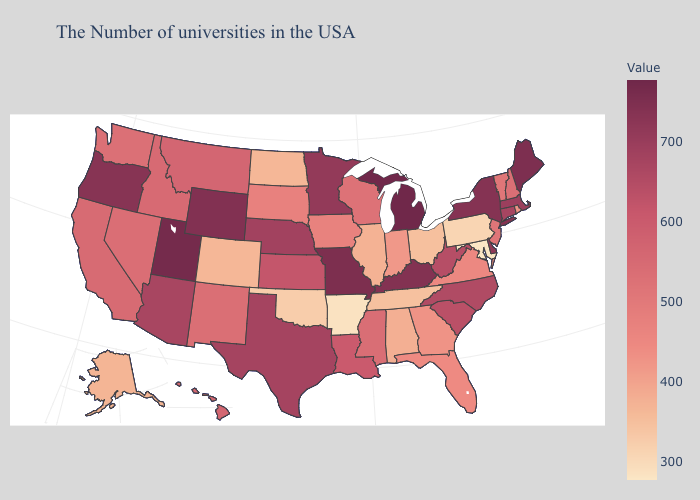Which states have the highest value in the USA?
Short answer required. Michigan. Does Alabama have the highest value in the South?
Give a very brief answer. No. Among the states that border Arkansas , which have the highest value?
Answer briefly. Missouri. Does Montana have a lower value than Utah?
Concise answer only. Yes. Which states have the lowest value in the USA?
Quick response, please. Maryland. Which states have the lowest value in the South?
Short answer required. Maryland. Among the states that border New York , does Vermont have the highest value?
Answer briefly. No. 